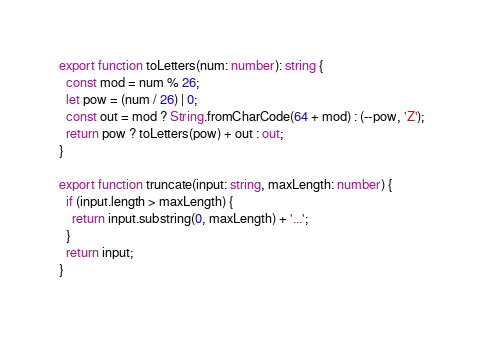Convert code to text. <code><loc_0><loc_0><loc_500><loc_500><_TypeScript_>export function toLetters(num: number): string {
  const mod = num % 26;
  let pow = (num / 26) | 0;
  const out = mod ? String.fromCharCode(64 + mod) : (--pow, 'Z');
  return pow ? toLetters(pow) + out : out;
}

export function truncate(input: string, maxLength: number) {
  if (input.length > maxLength) {
    return input.substring(0, maxLength) + '...';
  }
  return input;
}
</code> 